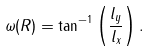<formula> <loc_0><loc_0><loc_500><loc_500>\omega ( R ) = \tan ^ { - 1 } \left ( \frac { l _ { y } } { l _ { x } } \right ) .</formula> 